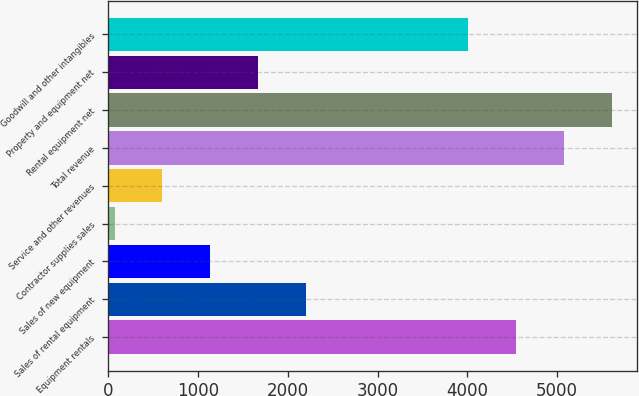Convert chart. <chart><loc_0><loc_0><loc_500><loc_500><bar_chart><fcel>Equipment rentals<fcel>Sales of rental equipment<fcel>Sales of new equipment<fcel>Contractor supplies sales<fcel>Service and other revenues<fcel>Total revenue<fcel>Rental equipment net<fcel>Property and equipment net<fcel>Goodwill and other intangibles<nl><fcel>4546.9<fcel>2201.6<fcel>1135.8<fcel>70<fcel>602.9<fcel>5079.8<fcel>5612.7<fcel>1668.7<fcel>4014<nl></chart> 